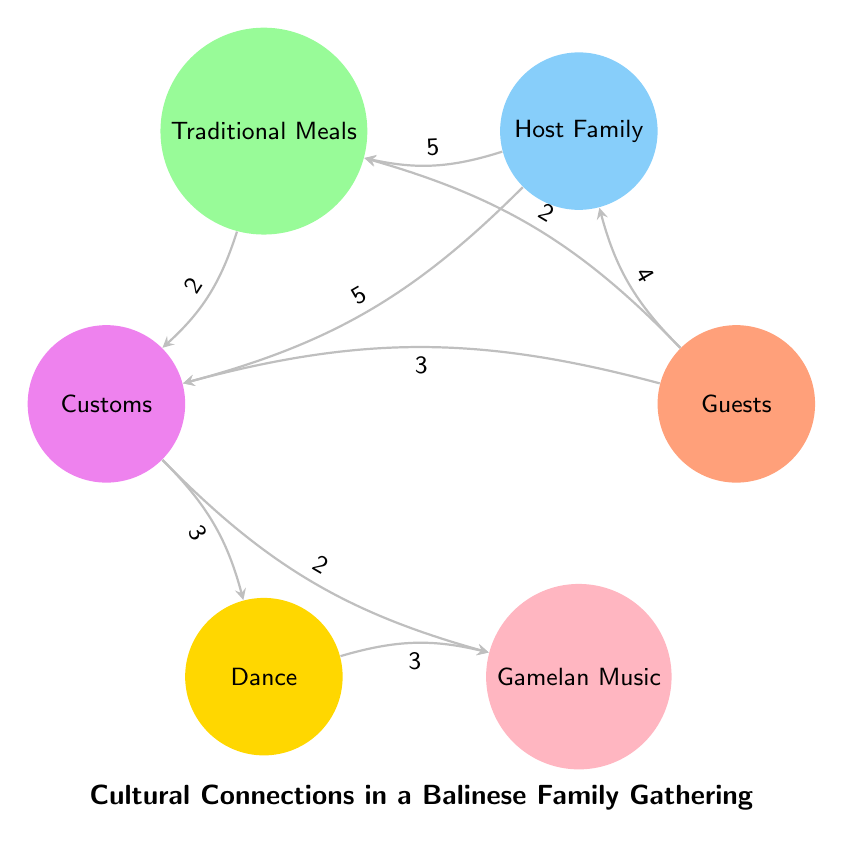What is the total number of nodes in the diagram? The diagram shows six distinct nodes, which are Guests, Host Family, Traditional Meals, Customs, Dance, and Gamelan Music. Counting them gives a total of six nodes.
Answer: 6 What value connects Guests to Traditional Meals? According to the diagram, the connection between Guests and Traditional Meals has a value of 2. This value indicates the strength or significance of this relationship.
Answer: 2 How many connections does Customs have to Dance? The diagram shows a single connection from Customs to Dance with a value of 3, indicating how often or how strong this connection is represented.
Answer: 3 What is the highest value connection in the diagram? To find the highest value connection, we look for the largest number among the values. The highest value in the diagram is 5, which connects Host Family to both Traditional Meals and Customs.
Answer: 5 Which two nodes share a connection with the same value? The nodes Traditional Meals and Customs have a connection with a value of 2. Additionally, the connection between Dance and Gamelan Music also has a value of 3. Both pairs of nodes share connections with different values but this highlights the relationships in the diagram.
Answer: Traditional Meals and Customs What are the two nodes that connect to Gamelan Music? The diagram shows that Gamelan Music is connected to Customs (with a value of 2) and also to Dance (with a value of 3). These connections represent different aspects of the cultural gathering.
Answer: Customs and Dance How many relationships are connected to the Host Family? The Host Family has two connections: one to Traditional Meals (with a value of 5) and one to Customs (with a value of 5). This indicates the family's strong involvement in providing meals and customs during the gathering.
Answer: 2 What does a value of 4 indicate in the relationship between Guests and Host Family? The value of 4 in the relationship between Guests and Host Family represents a strong connection, suggesting a warm and inviting atmosphere for interaction. It reflects the significance of the relationship in the context of the gathering.
Answer: 4 What is the relationship between Customs and Gamelan Music? Customs connects to Gamelan Music with a value of 2. This connection highlights the cultural importance of music in the customs shared during the family gathering.
Answer: 2 